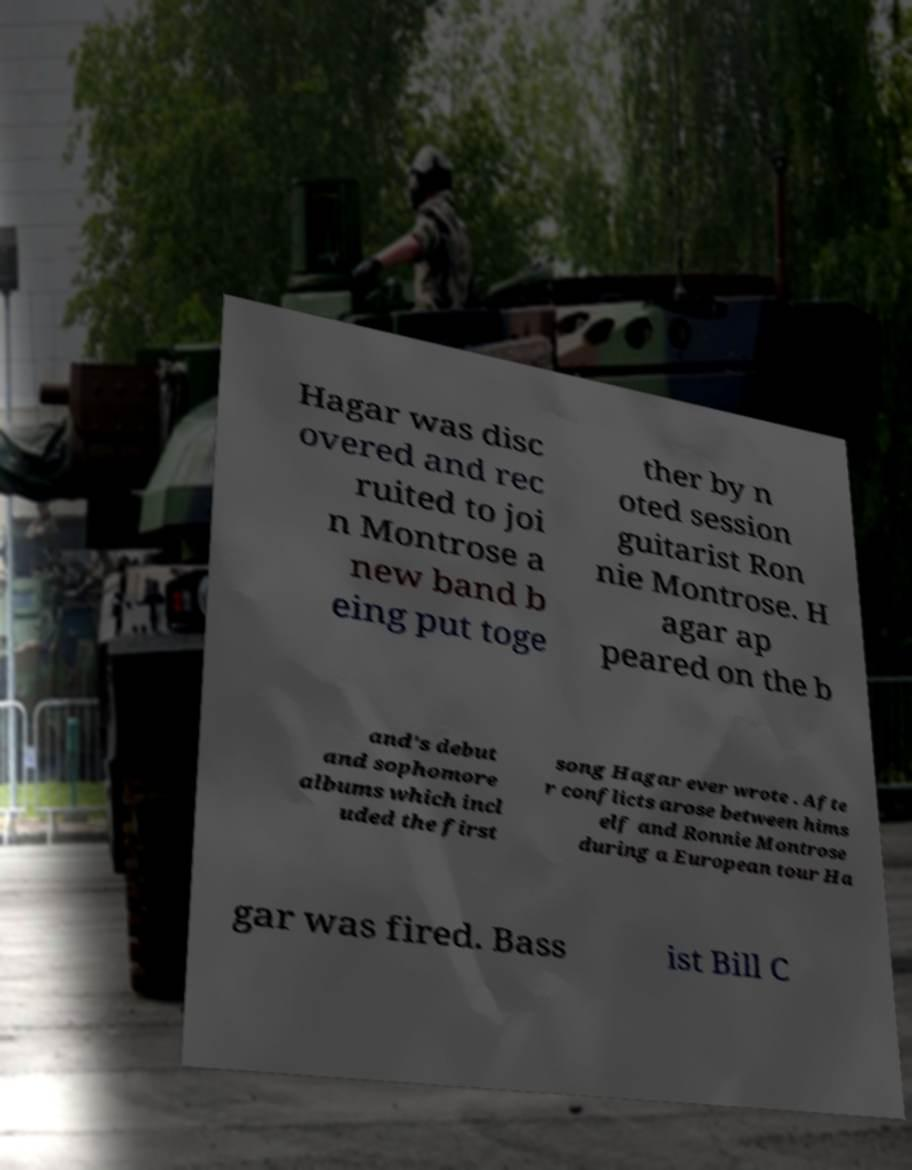What messages or text are displayed in this image? I need them in a readable, typed format. Hagar was disc overed and rec ruited to joi n Montrose a new band b eing put toge ther by n oted session guitarist Ron nie Montrose. H agar ap peared on the b and's debut and sophomore albums which incl uded the first song Hagar ever wrote . Afte r conflicts arose between hims elf and Ronnie Montrose during a European tour Ha gar was fired. Bass ist Bill C 